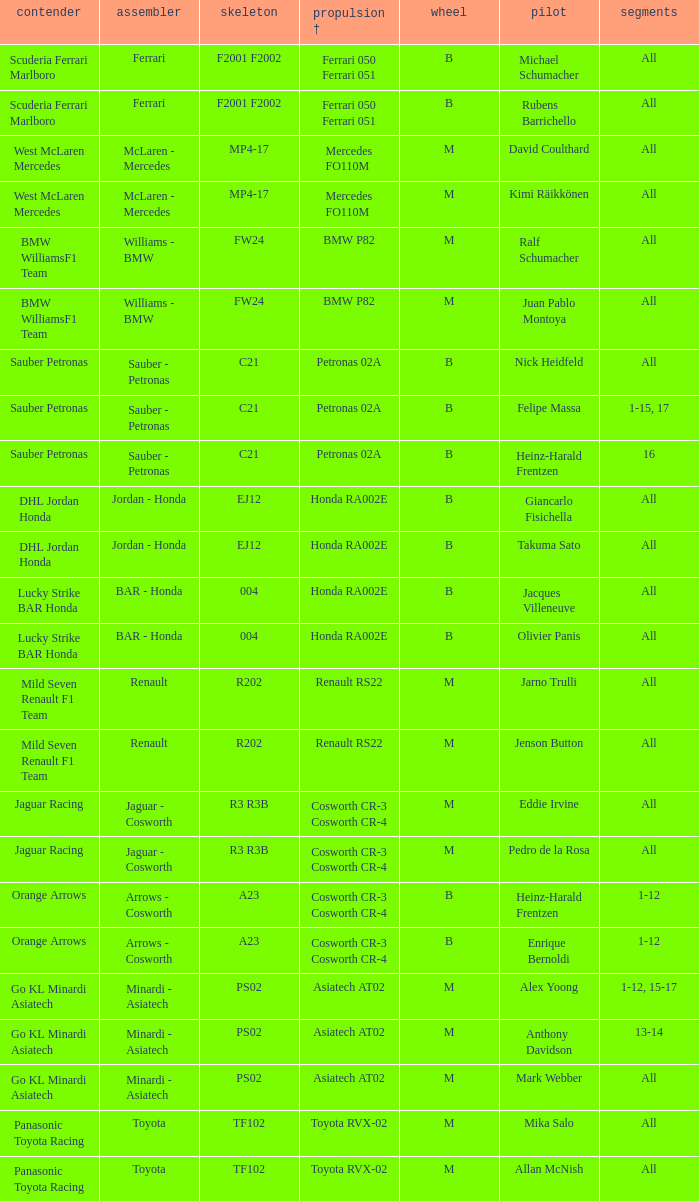What is the engine when the rounds ar all, the tyre is m and the driver is david coulthard? Mercedes FO110M. 